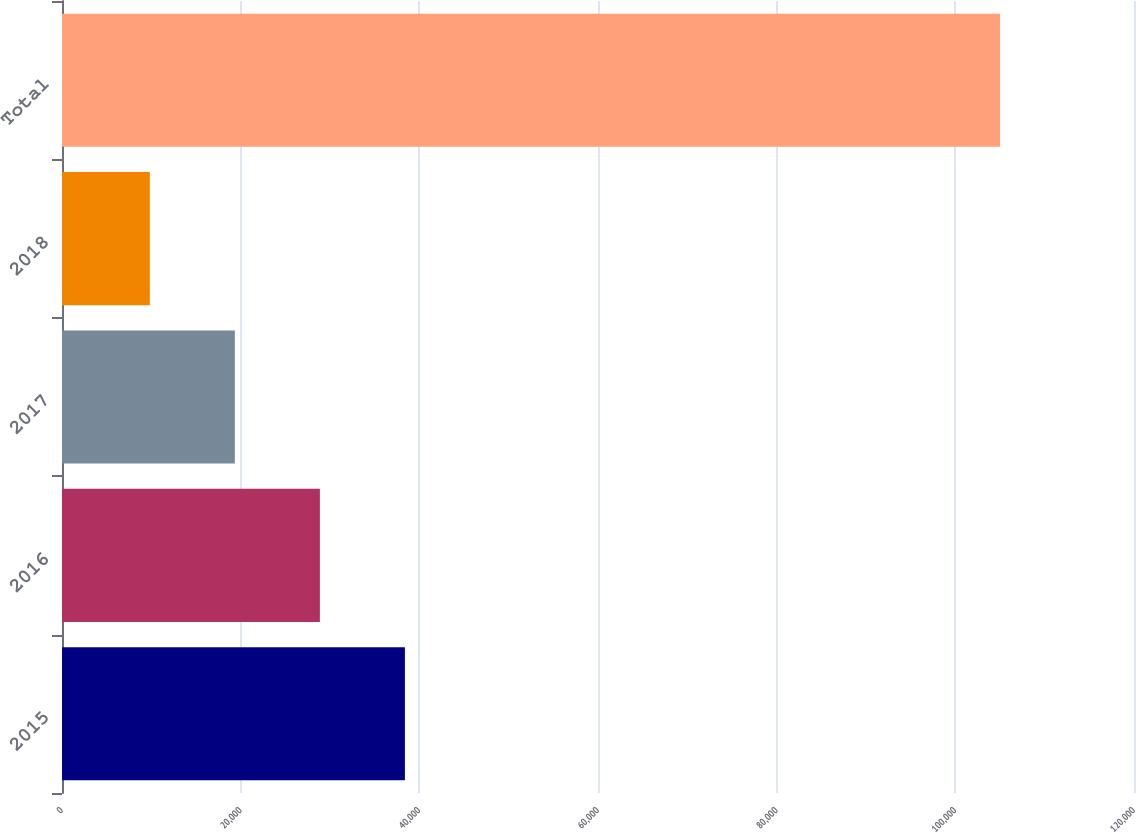<chart> <loc_0><loc_0><loc_500><loc_500><bar_chart><fcel>2015<fcel>2016<fcel>2017<fcel>2018<fcel>Total<nl><fcel>38385.7<fcel>28867.8<fcel>19349.9<fcel>9832<fcel>105011<nl></chart> 